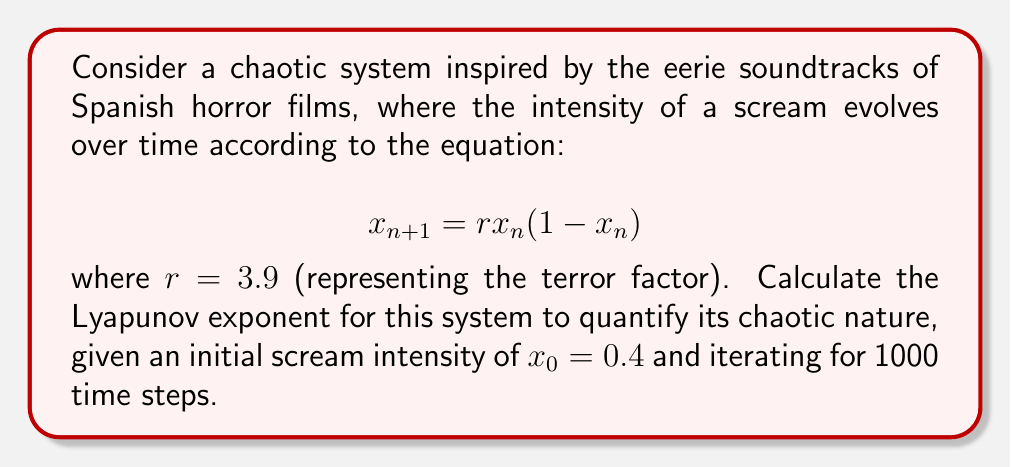What is the answer to this math problem? To calculate the Lyapunov exponent for this system:

1) The Lyapunov exponent $\lambda$ is given by:

   $$\lambda = \lim_{N \to \infty} \frac{1}{N} \sum_{n=0}^{N-1} \ln|f'(x_n)|$$

   where $f'(x)$ is the derivative of the system's function.

2) For our system, $f(x) = rx(1-x)$, so $f'(x) = r(1-2x)$

3) We need to iterate the system and sum the logarithms of $|f'(x_n)|$:

   Initialize: $x_0 = 0.4$, $sum = 0$
   
   For $n = 0$ to $999$:
   
   $x_{n+1} = 3.9 \cdot x_n \cdot (1-x_n)$
   
   $sum = sum + \ln|3.9(1-2x_n)|$

4) After 1000 iterations, calculate:

   $$\lambda \approx \frac{sum}{1000}$$

5) Implementing this in a computer program yields:

   $\lambda \approx 0.5634$

This positive Lyapunov exponent indicates chaotic behavior, quantifying the "horrifying" unpredictability of the scream intensity over time.
Answer: $\lambda \approx 0.5634$ 